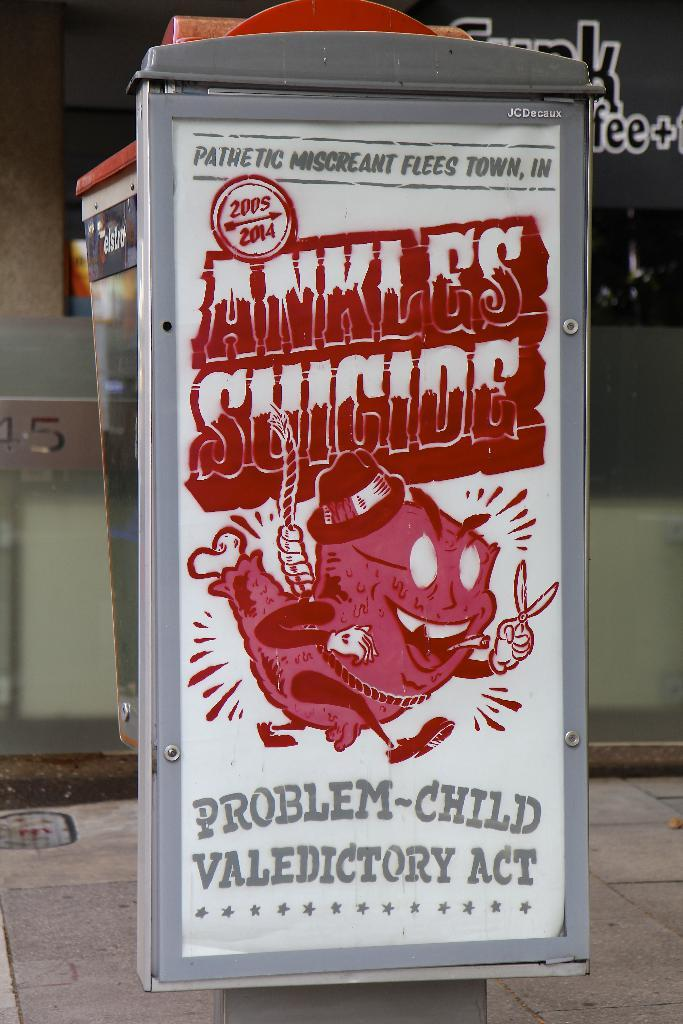What is the main object in the middle of the picture? There is an advertisement board in the middle of the picture. What can be found on the advertisement board? There is text on the advertisement board. Is there a river flowing behind the advertisement board in the image? There is no river visible in the image; it only features an advertisement board with text. 